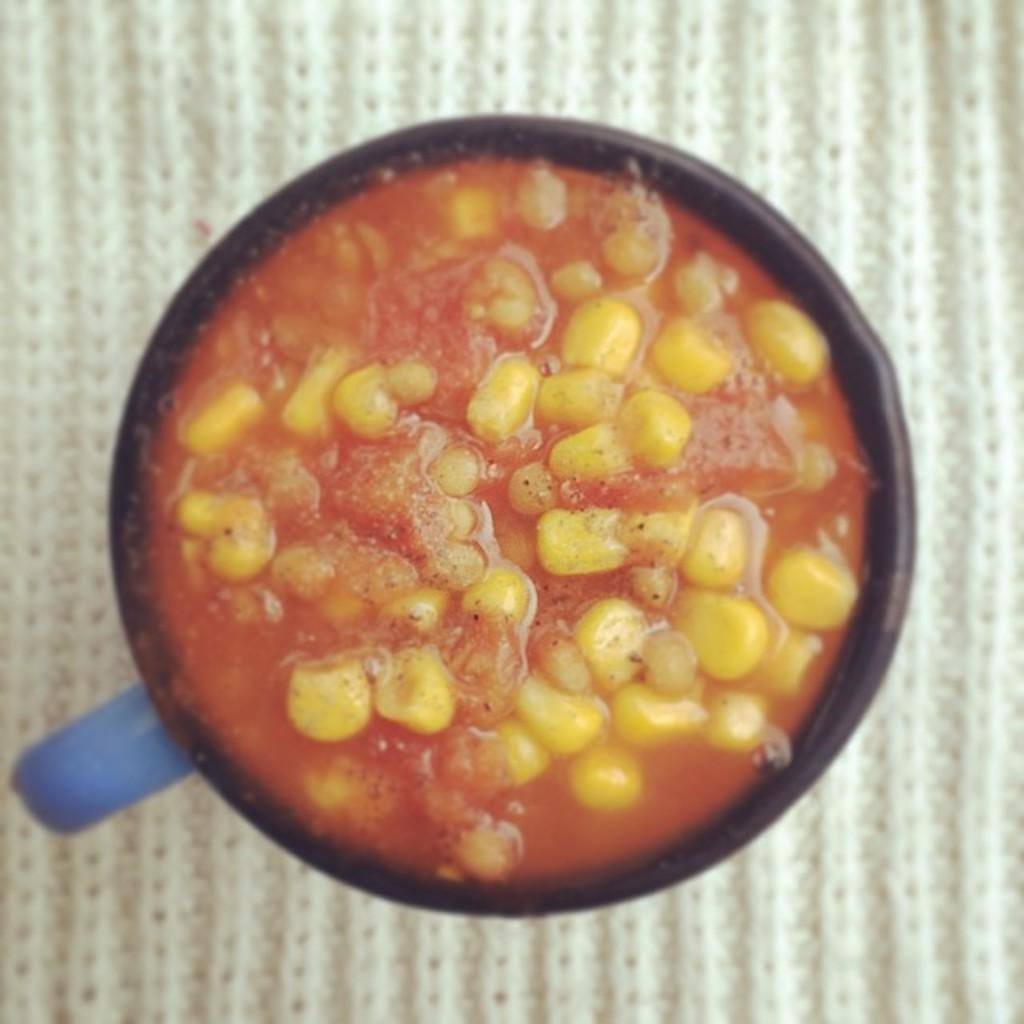What is the color of the vessel in the image? The vessel in the image is black. What is inside the black vessel? The black vessel contains a food item. What is the vessel placed on in the image? The black vessel is placed on a white mat. How many bikes are parked next to the black vessel in the image? There are no bikes present in the image. What type of lip can be seen on the food item inside the black vessel? There is no lip visible on the food item inside the black vessel. 